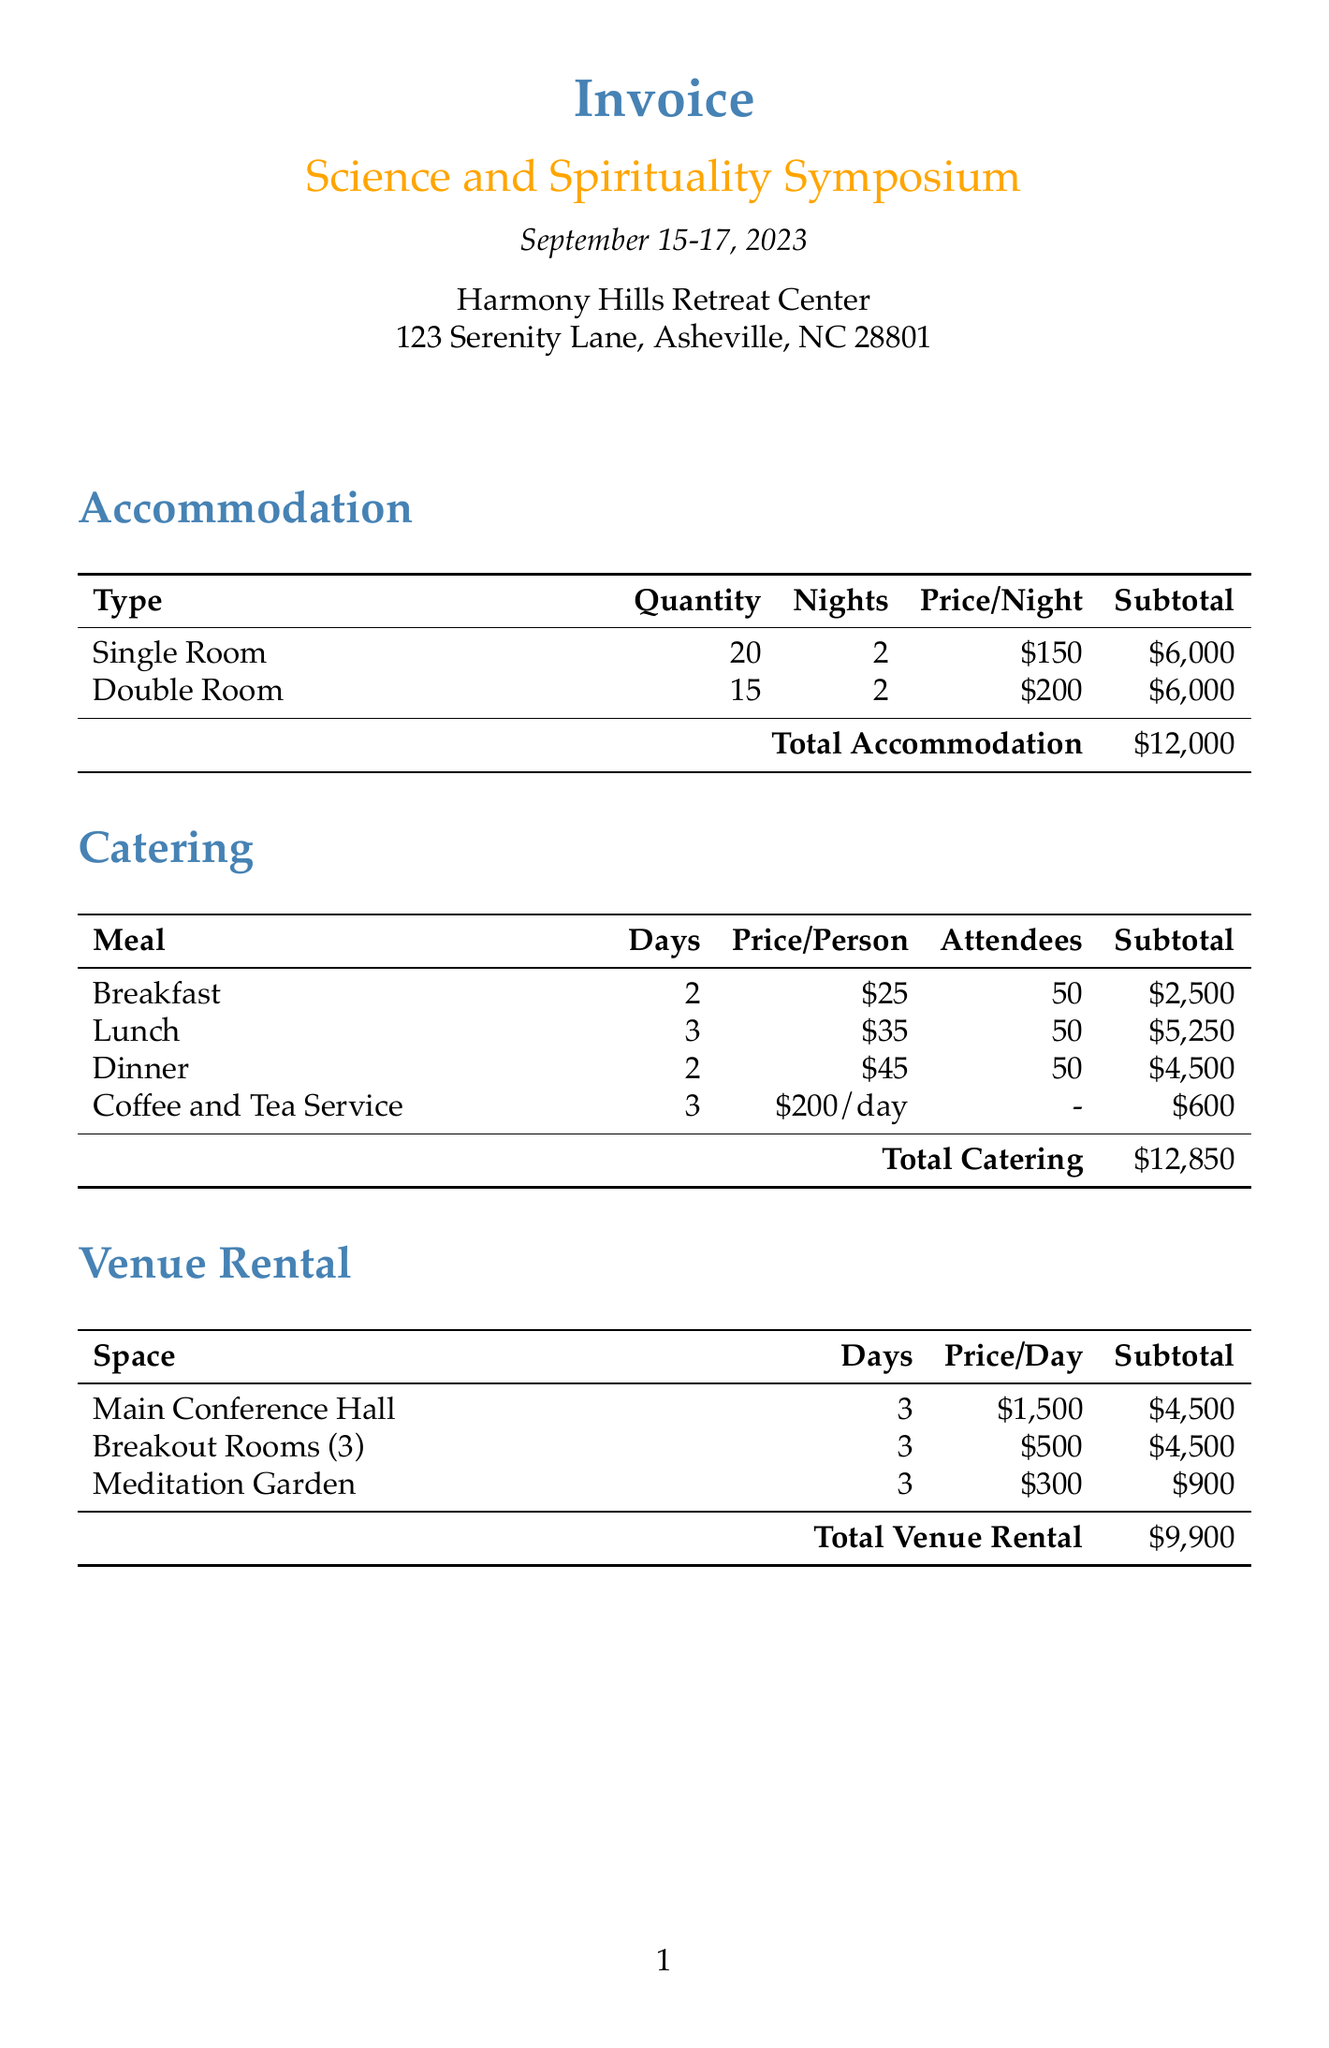what is the event name? The event name is stated at the top of the document under the purpose of the invoice.
Answer: Science and Spirituality Symposium what are the dates of the event? The dates of the event are mentioned right below the event name in the document.
Answer: September 15-17, 2023 how many single rooms were booked? The quantity of single rooms booked is listed in the accommodation section of the invoice.
Answer: 20 what is the total cost for catering? The total cost for catering is calculated from the subtotal of each meal service mentioned in the catering section.
Answer: 12,850 who is the speaker discussing the topic "The Convergence of Quantum Physics and Consciousness"? The speaker's name is clearly associated with the specific topic in the speakers section of the document.
Answer: Dr. Deepak Chopra what is the rental cost for the Main Conference Hall? The rental cost for the Main Conference Hall is shown in the venue rental section under the respective space.
Answer: 4,500 how many attendees are expected for the event? The number of attendees is specified in the catering section, indicating how many individuals the catering costs were based on.
Answer: 50 what is the total invoice amount? The total invoice amount is summarized at the bottom of the document, reflecting the complete costs incurred.
Answer: 64,750 how many guided nature walk sessions were arranged? The number of guided nature walk sessions is indicated in the special services section of the invoice.
Answer: 2 